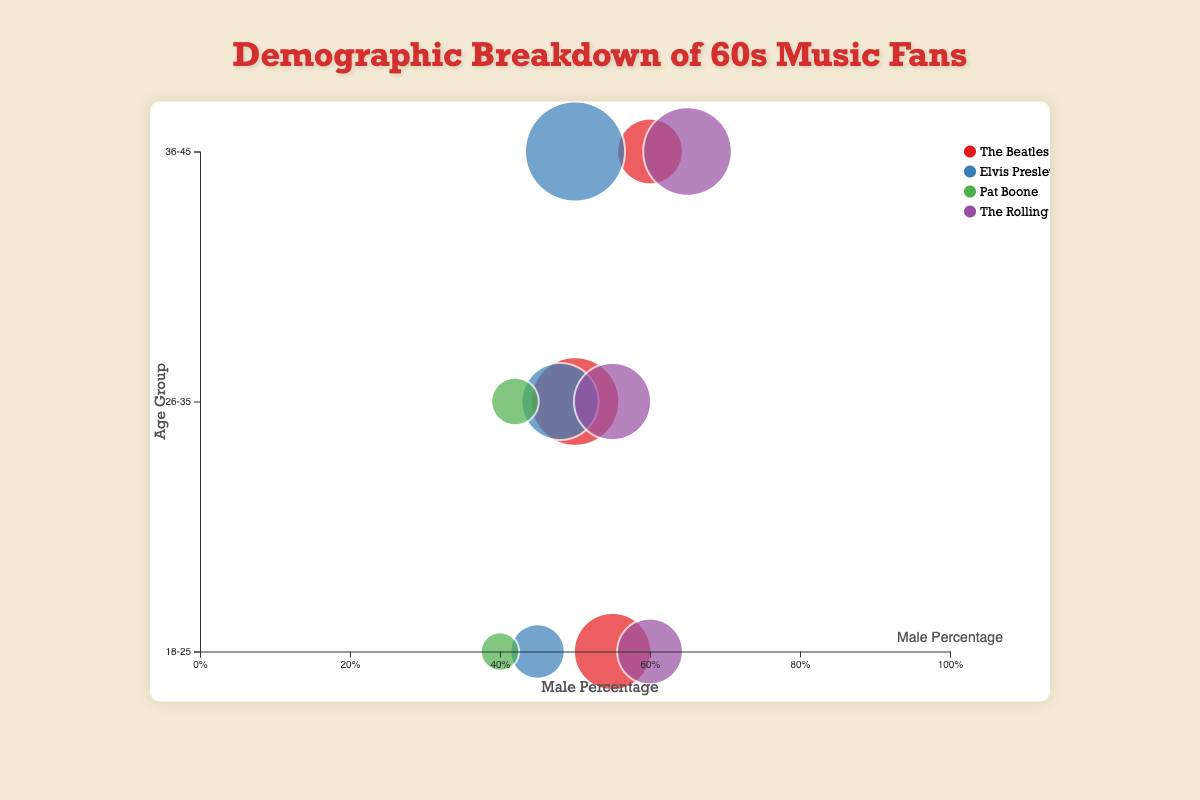What's the title of the chart? The title is located at the top of the chart, prominently displayed in large text. It reads: "Demographic Breakdown of 60s Music Fans"
Answer: Demographic Breakdown of 60s Music Fans Which artist has the largest bubble for the 36-45 age group? The size of the bubble indicates the percentage of fans in that age group. For the 36-45 age group, the largest bubble represents Elvis Presley, which has a percentage of 35%
Answer: Elvis Presley What is the color used for representing Pat Boone in the chart? Each artist is represented by a distinct color. Pat Boone's color in the legend is green
Answer: Green Which age group of The Rolling Stones fans has the highest male percentage? To determine this, we look at the positions of the bubbles in The Rolling Stones' color along the x-axis (male percentage) within each age group. The 36-45 age group bubble for The Rolling Stones is farthest to the right, indicating the highest male percentage of 65%
Answer: 36-45 How many age groups are represented in the chart? The y-axis labels indicate the age groups represented in the chart. There are three different age groups: 18-25, 26-35, and 36-45
Answer: 3 Between The Beatles and The Rolling Stones, which artist has the bubble with a larger radius for the 26-35 age group? The bubble size represents the percentage of fans. For the 26-35 age group, the bubble for The Beatles is larger than that for The Rolling Stones, indicating a higher percentage of fans for The Beatles
Answer: The Beatles What is the percentage difference between The Beatles' 18-25 age group and Elvis Presley's 26-35 age group? The Beatles' 18-25 age group has 25% fans, and Elvis Presley's 26-35 age group has 25% fans. The difference is 25% - 25% = 0%
Answer: 0% Which artist has a higher female distribution in the 18-25 age group, The Beatles or Elvis Presley? By examining the gender distribution for the 18-25 age group, Elvis Presley has a higher female percentage (55%) compared to The Beatles (45%)
Answer: Elvis Presley Is there an artist with a 50-50 male-to-female ratio in any age group? From the gender distribution provided, The Beatles in the 26-35 age group and Elvis Presley in the 36-45 age group have an exact 50% male to 50% female ratio
Answer: Yes 